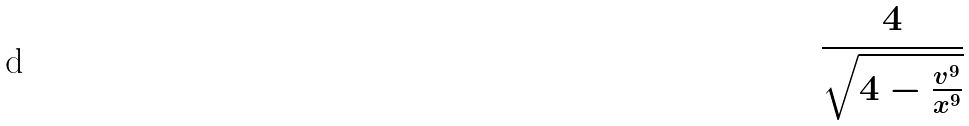<formula> <loc_0><loc_0><loc_500><loc_500>\frac { 4 } { \sqrt { 4 - \frac { v ^ { 9 } } { x ^ { 9 } } } }</formula> 